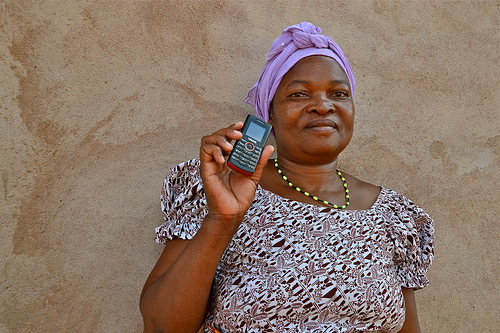<image>
Is there a phone behind the woman? No. The phone is not behind the woman. From this viewpoint, the phone appears to be positioned elsewhere in the scene. 